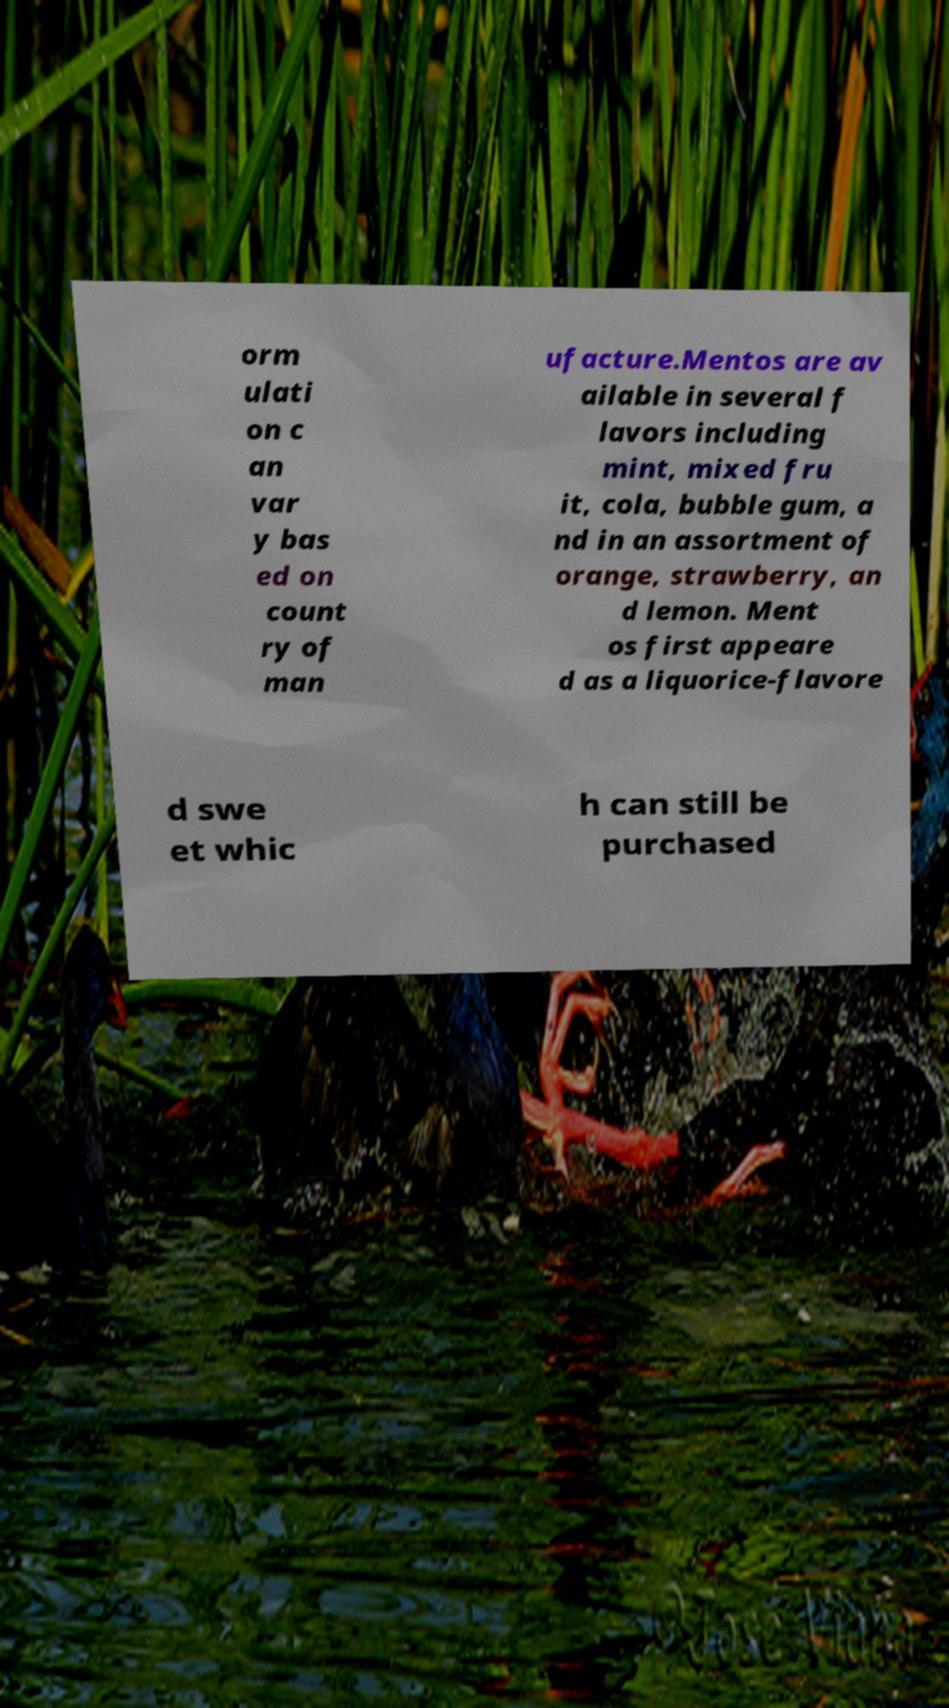Please identify and transcribe the text found in this image. orm ulati on c an var y bas ed on count ry of man ufacture.Mentos are av ailable in several f lavors including mint, mixed fru it, cola, bubble gum, a nd in an assortment of orange, strawberry, an d lemon. Ment os first appeare d as a liquorice-flavore d swe et whic h can still be purchased 